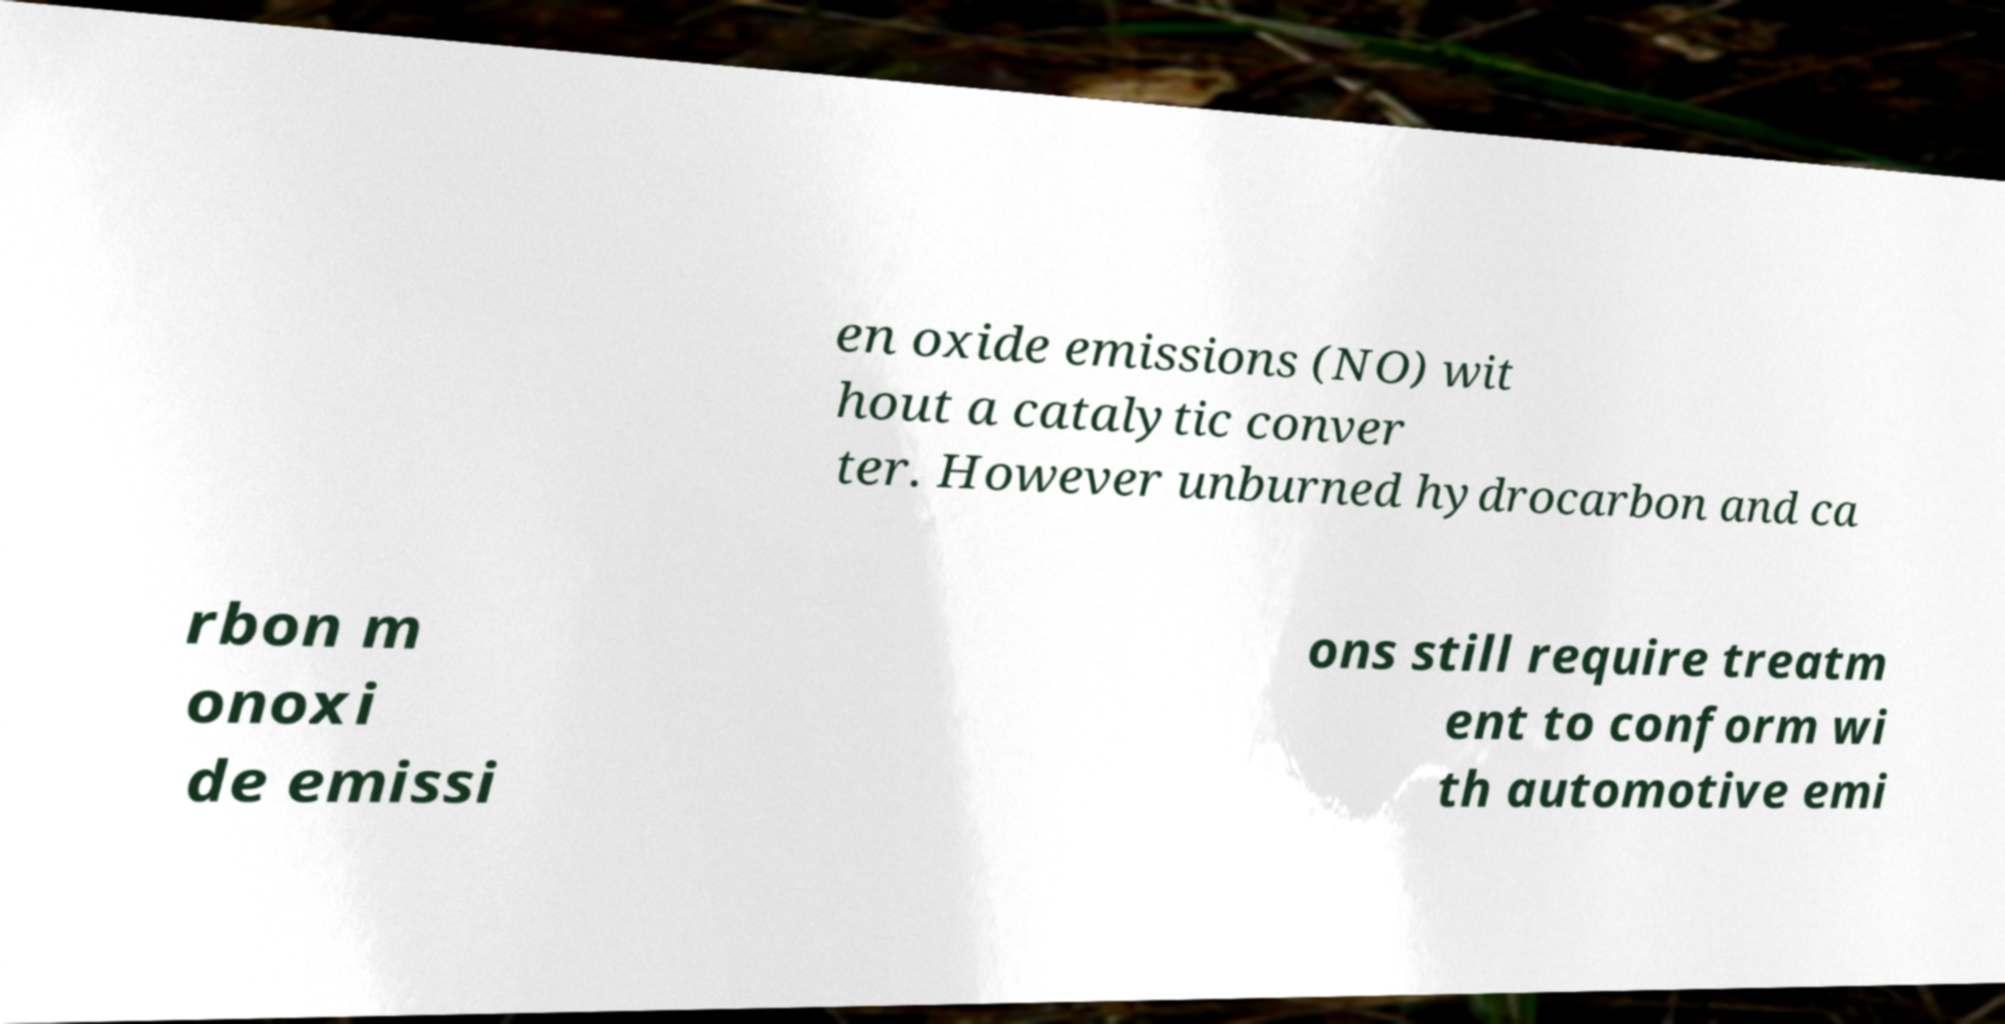What messages or text are displayed in this image? I need them in a readable, typed format. en oxide emissions (NO) wit hout a catalytic conver ter. However unburned hydrocarbon and ca rbon m onoxi de emissi ons still require treatm ent to conform wi th automotive emi 